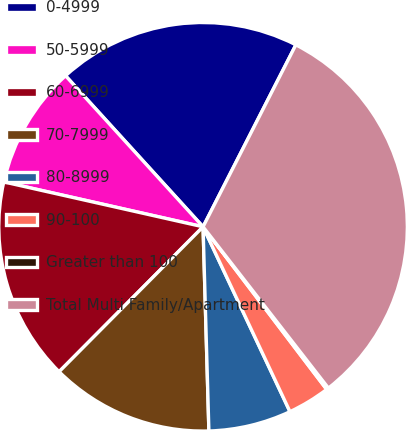<chart> <loc_0><loc_0><loc_500><loc_500><pie_chart><fcel>0-4999<fcel>50-5999<fcel>60-6999<fcel>70-7999<fcel>80-8999<fcel>90-100<fcel>Greater than 100<fcel>Total Multi Family/Apartment<nl><fcel>19.26%<fcel>9.72%<fcel>16.08%<fcel>12.9%<fcel>6.54%<fcel>3.35%<fcel>0.17%<fcel>31.98%<nl></chart> 